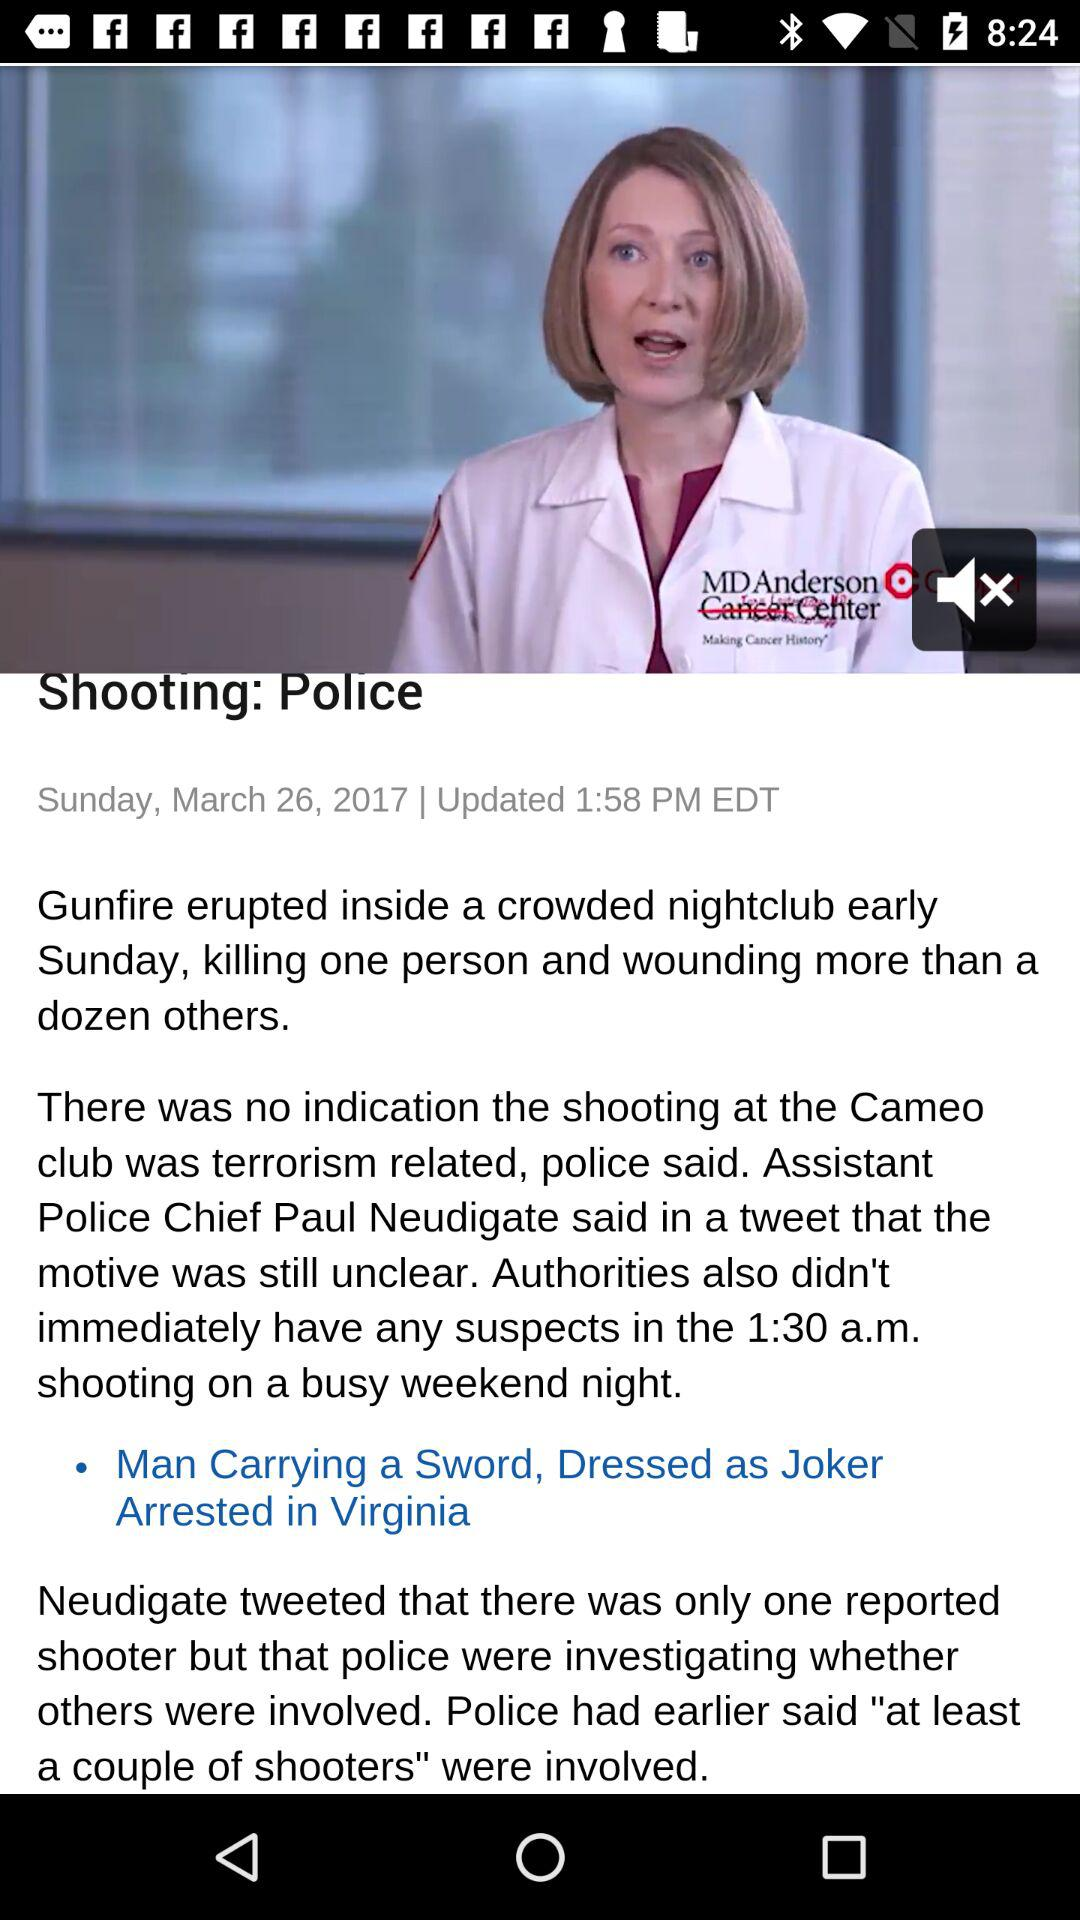When was the article updated? The article was updated at 1:58 PM EDT. 